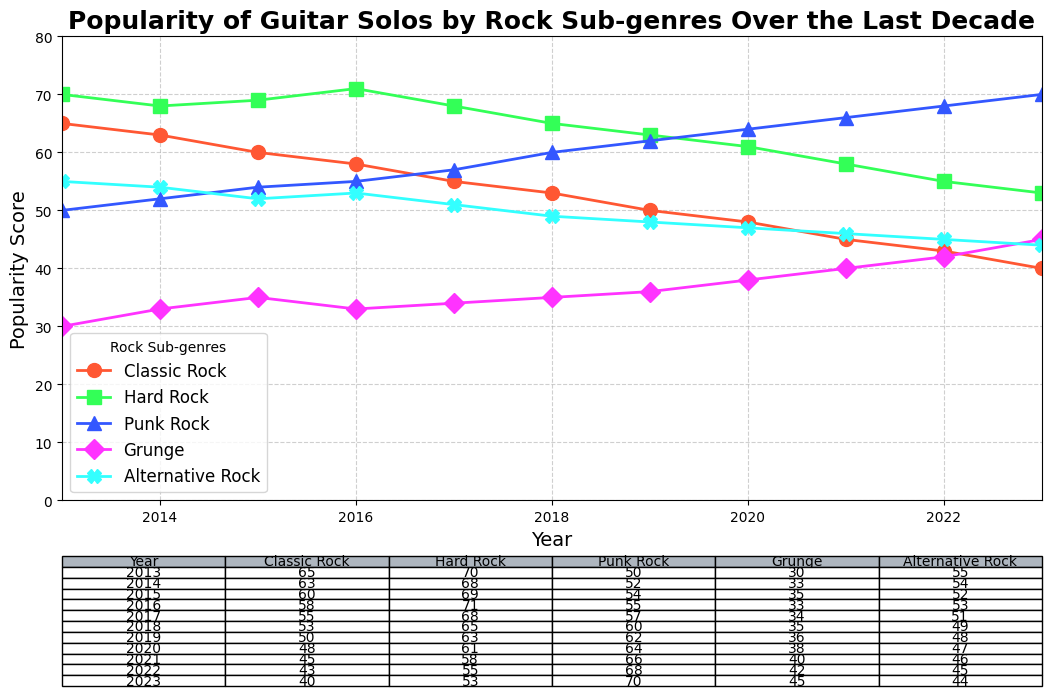What was the popularity score of Punk Rock in 2023? The table and the chart show the popularity score of Punk Rock for each year. For 2023, the value at the intersection of the Punk Rock column and the 2023 row shows 70.
Answer: 70 Which rock sub-genre had the highest popularity score in 2020? The highest popularity score for 2020 can be found by comparing the values for all sub-genres in that year in the chart. Punk Rock had the highest score with a value of 64.
Answer: Punk Rock Between 2013 and 2023, which rock sub-genre had the smallest decrease in popularity? By comparing the scores in 2013 and 2023 for each sub-genre, we calculate the decreases: Classic Rock (65 to 40 = -25), Hard Rock (70 to 53 = -17), Punk Rock (50 to 70 = +20), Grunge (30 to 45 = +15), and Alternative Rock (55 to 44 = -11). Considering positive changes as increases and looking at purely decreases, the smallest decrease is for Alternative Rock with -11.
Answer: Alternative Rock In which year did Classic Rock and Grunge have the closest popularity scores, and what were those scores? By comparing the values in each year for Classic Rock and Grunge, the smallest difference can be found by seeing the year where the scores for these two sub-genres are the closest. In 2023, Classic Rock scored 40 and Grunge scored 45, making the difference 5.
Answer: 2023 and scores were Classic Rock: 40, Grunge: 45 What's the average popularity score of Alternative Rock over the last decade? Summing all the values for Alternative Rock from 2013 to 2023 (55 + 54 + 52 + 53 + 51 + 49 + 48 + 47 + 46 + 45 + 44 = 494) and dividing by the number of years (11) provides the average: 494 / 11 ≈ 44.91.
Answer: 44.91 Which rock sub-genre consistently increased in popularity from 2013 to 2023? By observing the trends on the chart, Punk Rock shows a consistent upward trend from 50 in 2013 to 70 in 2023 without any year-on-year decrease.
Answer: Punk Rock 